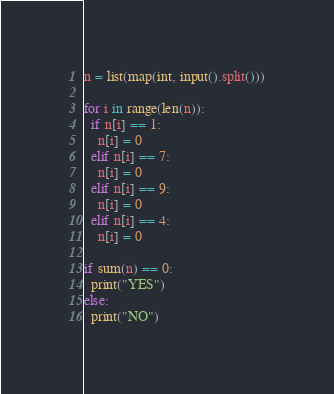<code> <loc_0><loc_0><loc_500><loc_500><_Python_>n = list(map(int, input().split()))

for i in range(len(n)):
  if n[i] == 1:
    n[i] = 0
  elif n[i] == 7:
    n[i] = 0
  elif n[i] == 9:
    n[i] = 0
  elif n[i] == 4:
    n[i] = 0
    
if sum(n) == 0:
  print("YES")
else:
  print("NO")</code> 